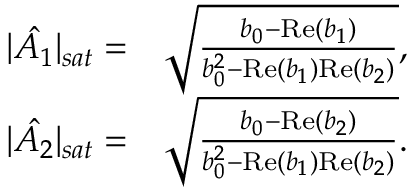<formula> <loc_0><loc_0><loc_500><loc_500>\begin{array} { r l } { | \hat { A _ { 1 } } | _ { s a t } = } & { \sqrt { \frac { b _ { 0 } - R e ( b _ { 1 } ) } { b _ { 0 } ^ { 2 } - R e ( b _ { 1 } ) R e ( b _ { 2 } ) } } , } \\ { | \hat { A _ { 2 } } | _ { s a t } = } & { \sqrt { \frac { b _ { 0 } - R e ( b _ { 2 } ) } { b _ { 0 } ^ { 2 } - R e ( b _ { 1 } ) R e ( b _ { 2 } ) } } . } \end{array}</formula> 